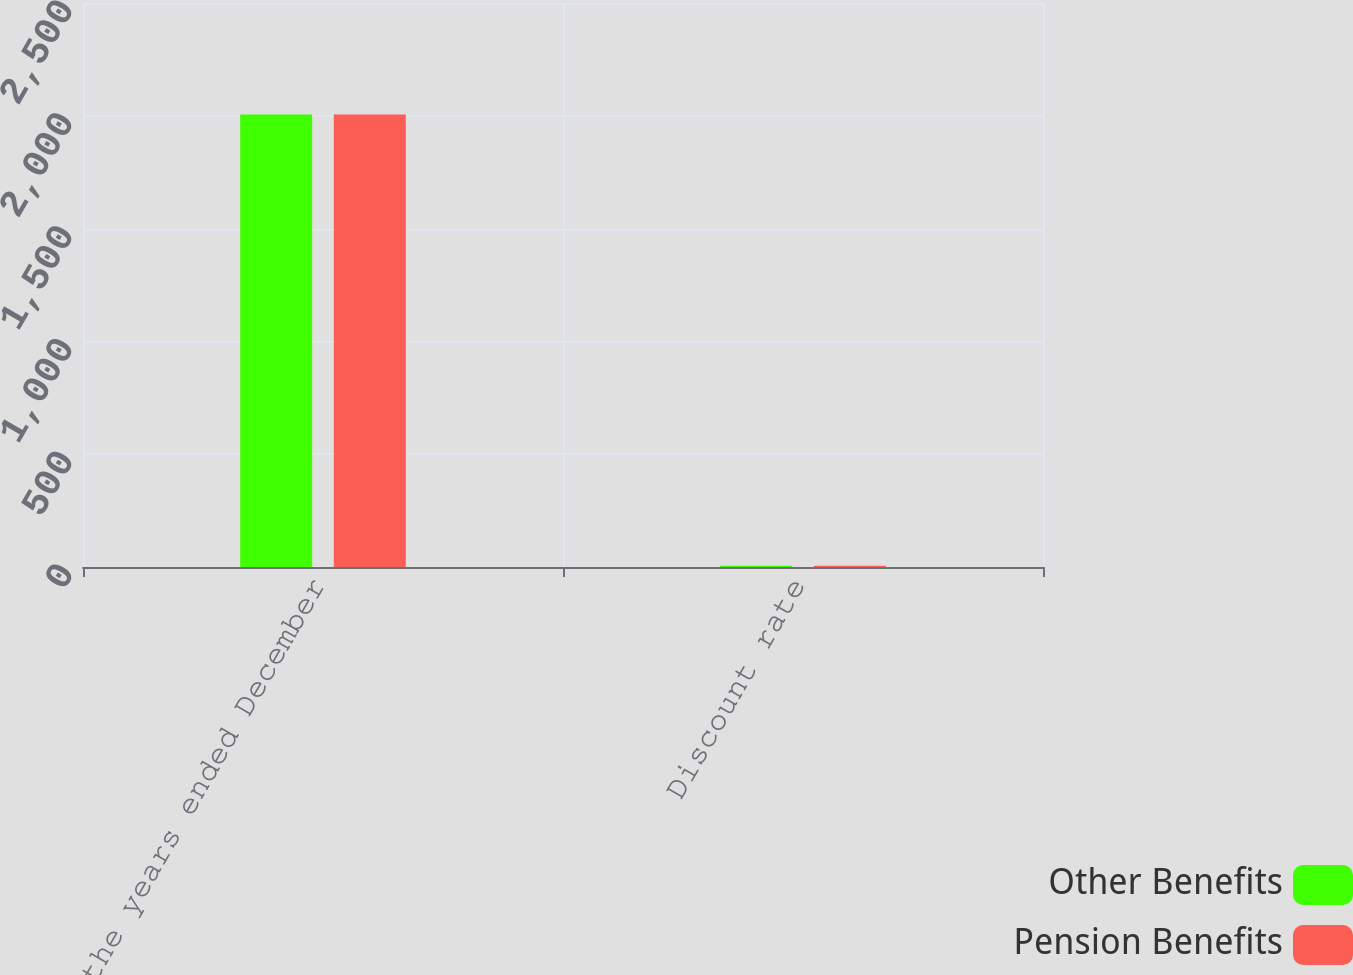Convert chart to OTSL. <chart><loc_0><loc_0><loc_500><loc_500><stacked_bar_chart><ecel><fcel>For the years ended December<fcel>Discount rate<nl><fcel>Other Benefits<fcel>2006<fcel>5.4<nl><fcel>Pension Benefits<fcel>2006<fcel>5.4<nl></chart> 